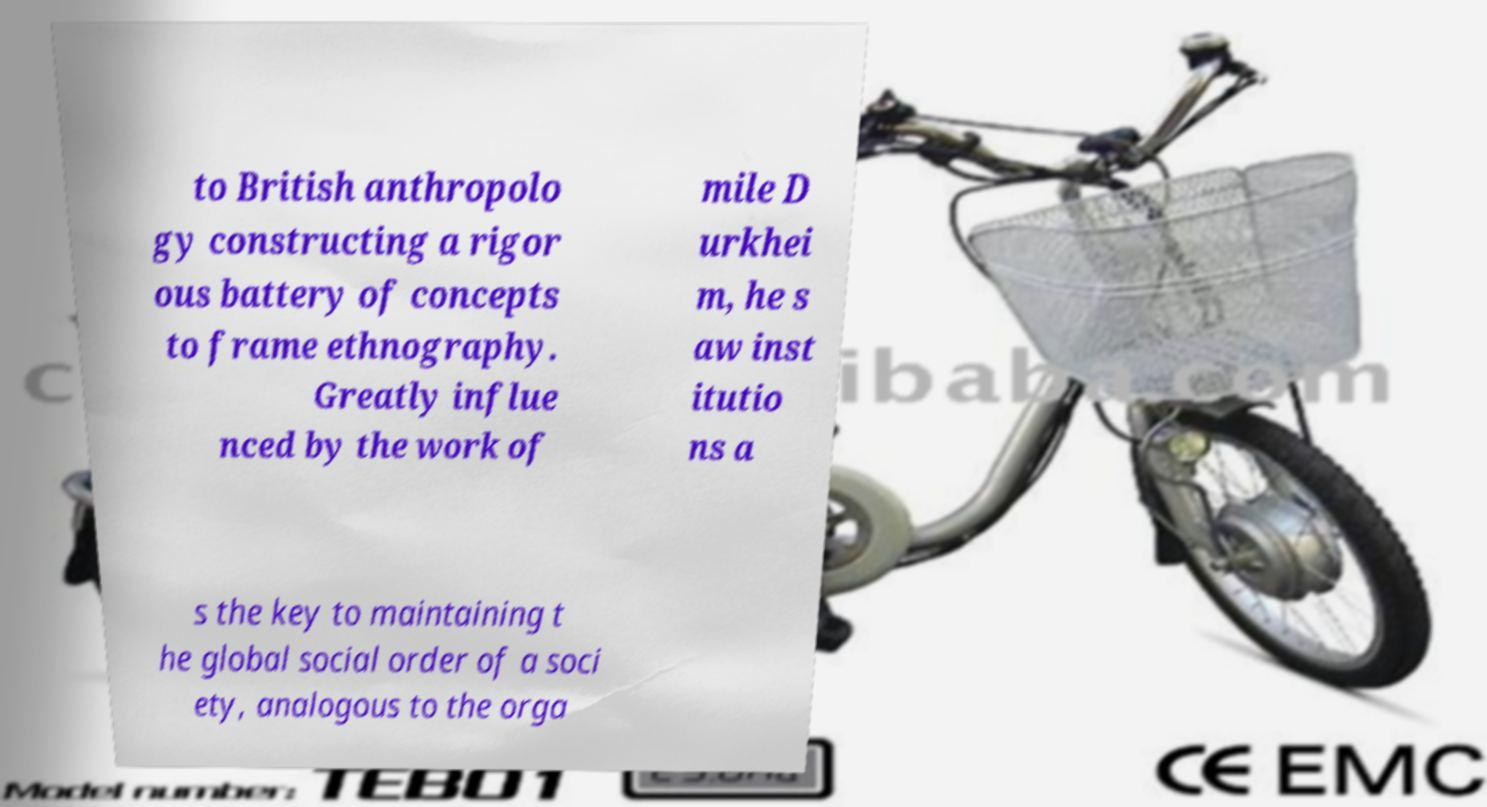Could you extract and type out the text from this image? to British anthropolo gy constructing a rigor ous battery of concepts to frame ethnography. Greatly influe nced by the work of mile D urkhei m, he s aw inst itutio ns a s the key to maintaining t he global social order of a soci ety, analogous to the orga 